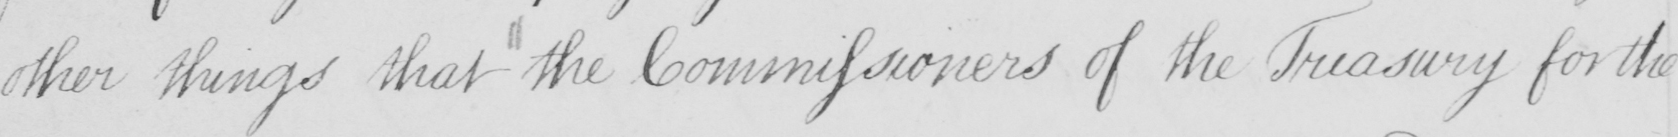Transcribe the text shown in this historical manuscript line. other things that the Commissioners of the Treasury for the 